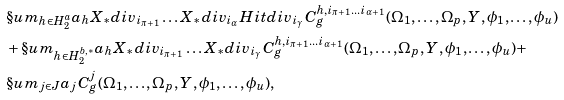<formula> <loc_0><loc_0><loc_500><loc_500>& \S u m _ { h \in H ^ { a } _ { 2 } } a _ { h } X _ { * } d i v _ { i _ { \pi + 1 } } \dots X _ { * } d i v _ { i _ { \alpha } } H i t d i v _ { i _ { \gamma } } C ^ { h , i _ { \pi + 1 } \dots i _ { \alpha + 1 } } _ { g } ( \Omega _ { 1 } , \dots , \Omega _ { p } , Y , \phi _ { 1 } , \dots , \phi _ { u } ) \\ & + \S u m _ { h \in H ^ { b , * } _ { 2 } } a _ { h } X _ { * } d i v _ { i _ { \pi + 1 } } \dots X _ { * } d i v _ { i _ { \gamma } } C ^ { h , i _ { \pi + 1 } \dots i _ { \alpha + 1 } } _ { g } ( \Omega _ { 1 } , \dots , \Omega _ { p } , Y , \phi _ { 1 } , \dots , \phi _ { u } ) + \\ & \S u m _ { j \in J } a _ { j } C ^ { j } _ { g } ( \Omega _ { 1 } , \dots , \Omega _ { p } , Y , \phi _ { 1 } , \dots , \phi _ { u } ) ,</formula> 